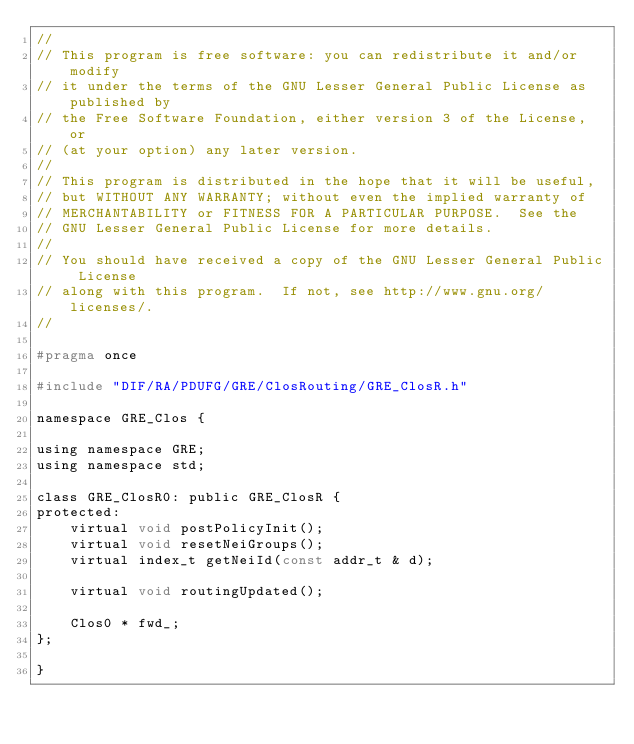<code> <loc_0><loc_0><loc_500><loc_500><_C_>//
// This program is free software: you can redistribute it and/or modify
// it under the terms of the GNU Lesser General Public License as published by
// the Free Software Foundation, either version 3 of the License, or
// (at your option) any later version.
// 
// This program is distributed in the hope that it will be useful,
// but WITHOUT ANY WARRANTY; without even the implied warranty of
// MERCHANTABILITY or FITNESS FOR A PARTICULAR PURPOSE.  See the
// GNU Lesser General Public License for more details.
// 
// You should have received a copy of the GNU Lesser General Public License
// along with this program.  If not, see http://www.gnu.org/licenses/.
// 

#pragma once

#include "DIF/RA/PDUFG/GRE/ClosRouting/GRE_ClosR.h"

namespace GRE_Clos {

using namespace GRE;
using namespace std;

class GRE_ClosR0: public GRE_ClosR {
protected:
    virtual void postPolicyInit();
    virtual void resetNeiGroups();
    virtual index_t getNeiId(const addr_t & d);

    virtual void routingUpdated();

    Clos0 * fwd_;
};

}
</code> 